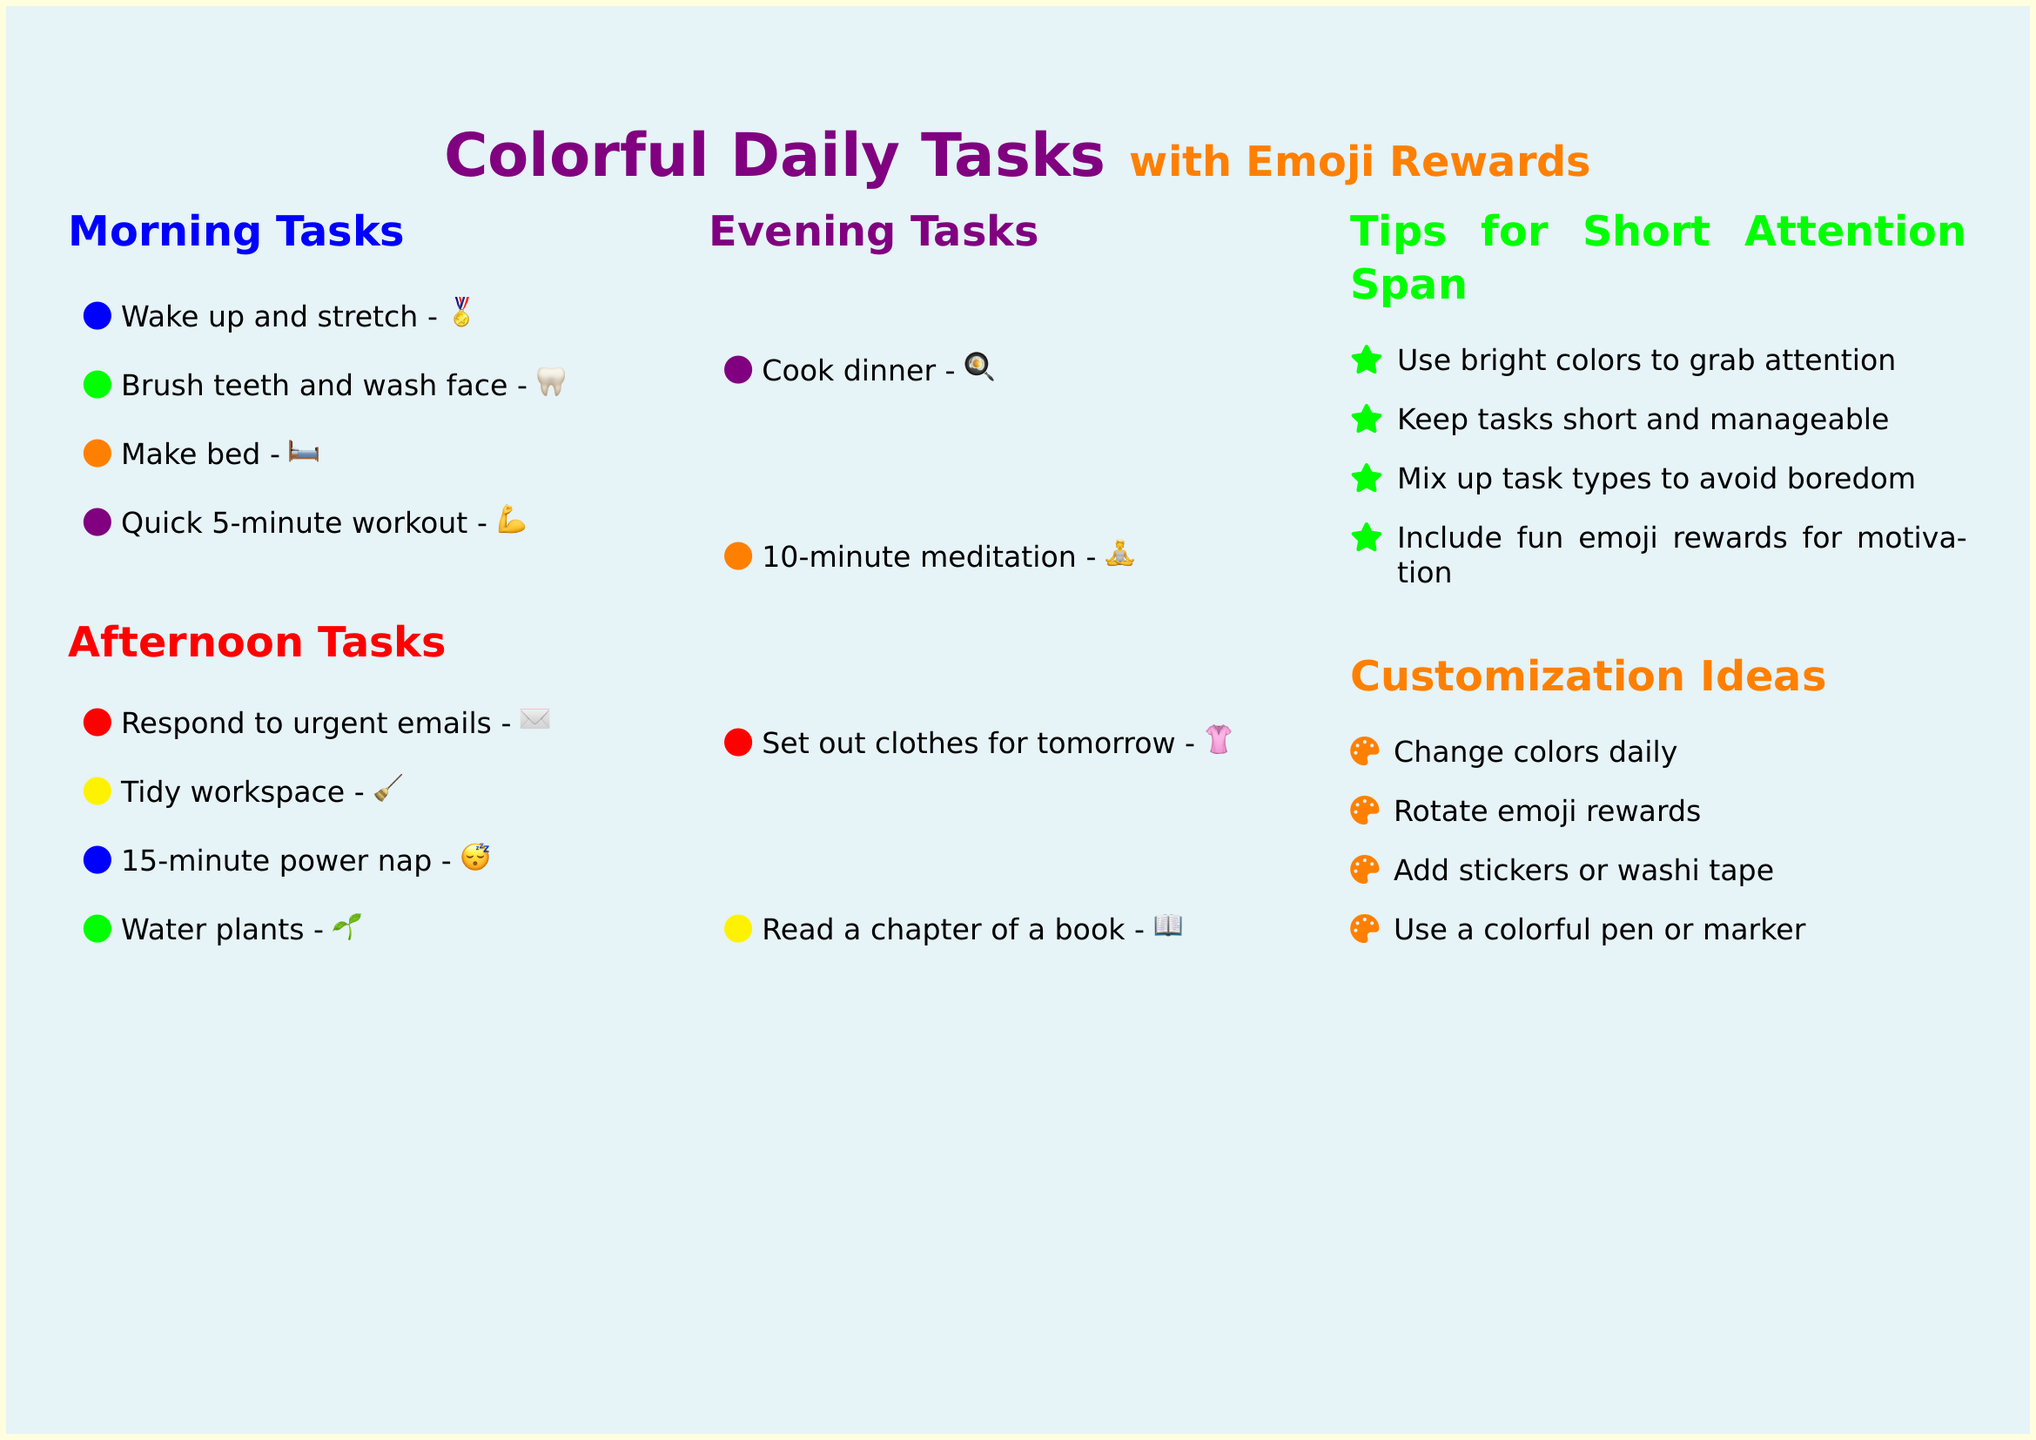What are the morning tasks? The morning tasks listed in the document are: Wake up and stretch, Brush teeth and wash face, Make bed, Quick 5-minute workout.
Answer: Wake up and stretch, Brush teeth and wash face, Make bed, Quick 5-minute workout How many tasks are in the afternoon section? There are four tasks listed in the afternoon section of the document.
Answer: 4 What emoji is used for "Cook dinner"? The emoji used for "Cook dinner" is a cooking emoji.
Answer: 🍳 Which task is associated with a green circle? The task associated with a green circle in the afternoon section is "Water plants."
Answer: Water plants What is a tip for someone with a short attention span? One of the tips for handling a short attention span is to "Keep tasks short and manageable."
Answer: Keep tasks short and manageable How can you customize the task list? One way to customize the task list is to "Change colors daily."
Answer: Change colors daily What’s the color of the heading for Evening Tasks? The color of the heading for Evening Tasks is violet.
Answer: violet How many total sections are there in the document? The document contains five sections in total.
Answer: 5 What reward emoji is given for brushing teeth? The reward emoji for brushing teeth is a tooth emoji.
Answer: 🦷 